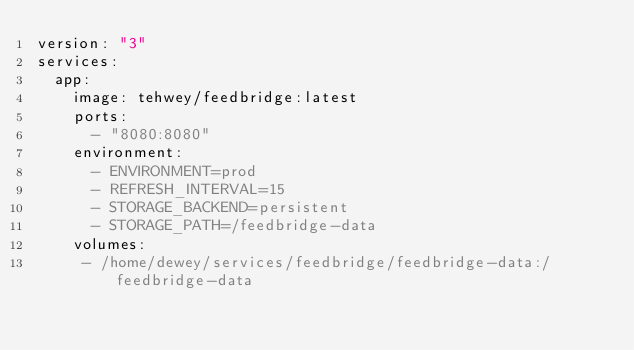Convert code to text. <code><loc_0><loc_0><loc_500><loc_500><_YAML_>version: "3"
services:
  app:
    image: tehwey/feedbridge:latest
    ports:
      - "8080:8080"
    environment:
      - ENVIRONMENT=prod
      - REFRESH_INTERVAL=15
      - STORAGE_BACKEND=persistent
      - STORAGE_PATH=/feedbridge-data
    volumes:
     - /home/dewey/services/feedbridge/feedbridge-data:/feedbridge-data
</code> 